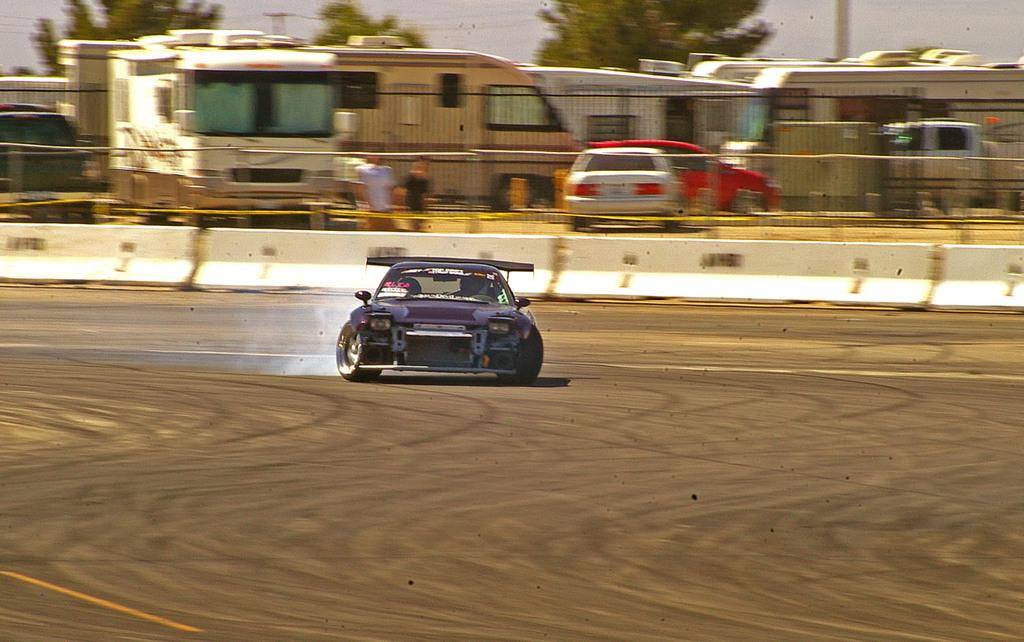What is the main subject of the image? There is a car in the center of the image. What is the car doing in the image? The car is moving on the ground. What can be seen in the background of the image? There are persons, vehicles, trees, and a fence. What type of mitten is being used to steer the car in the image? There is no mitten present in the image, and the car is not being steered by a mitten. 